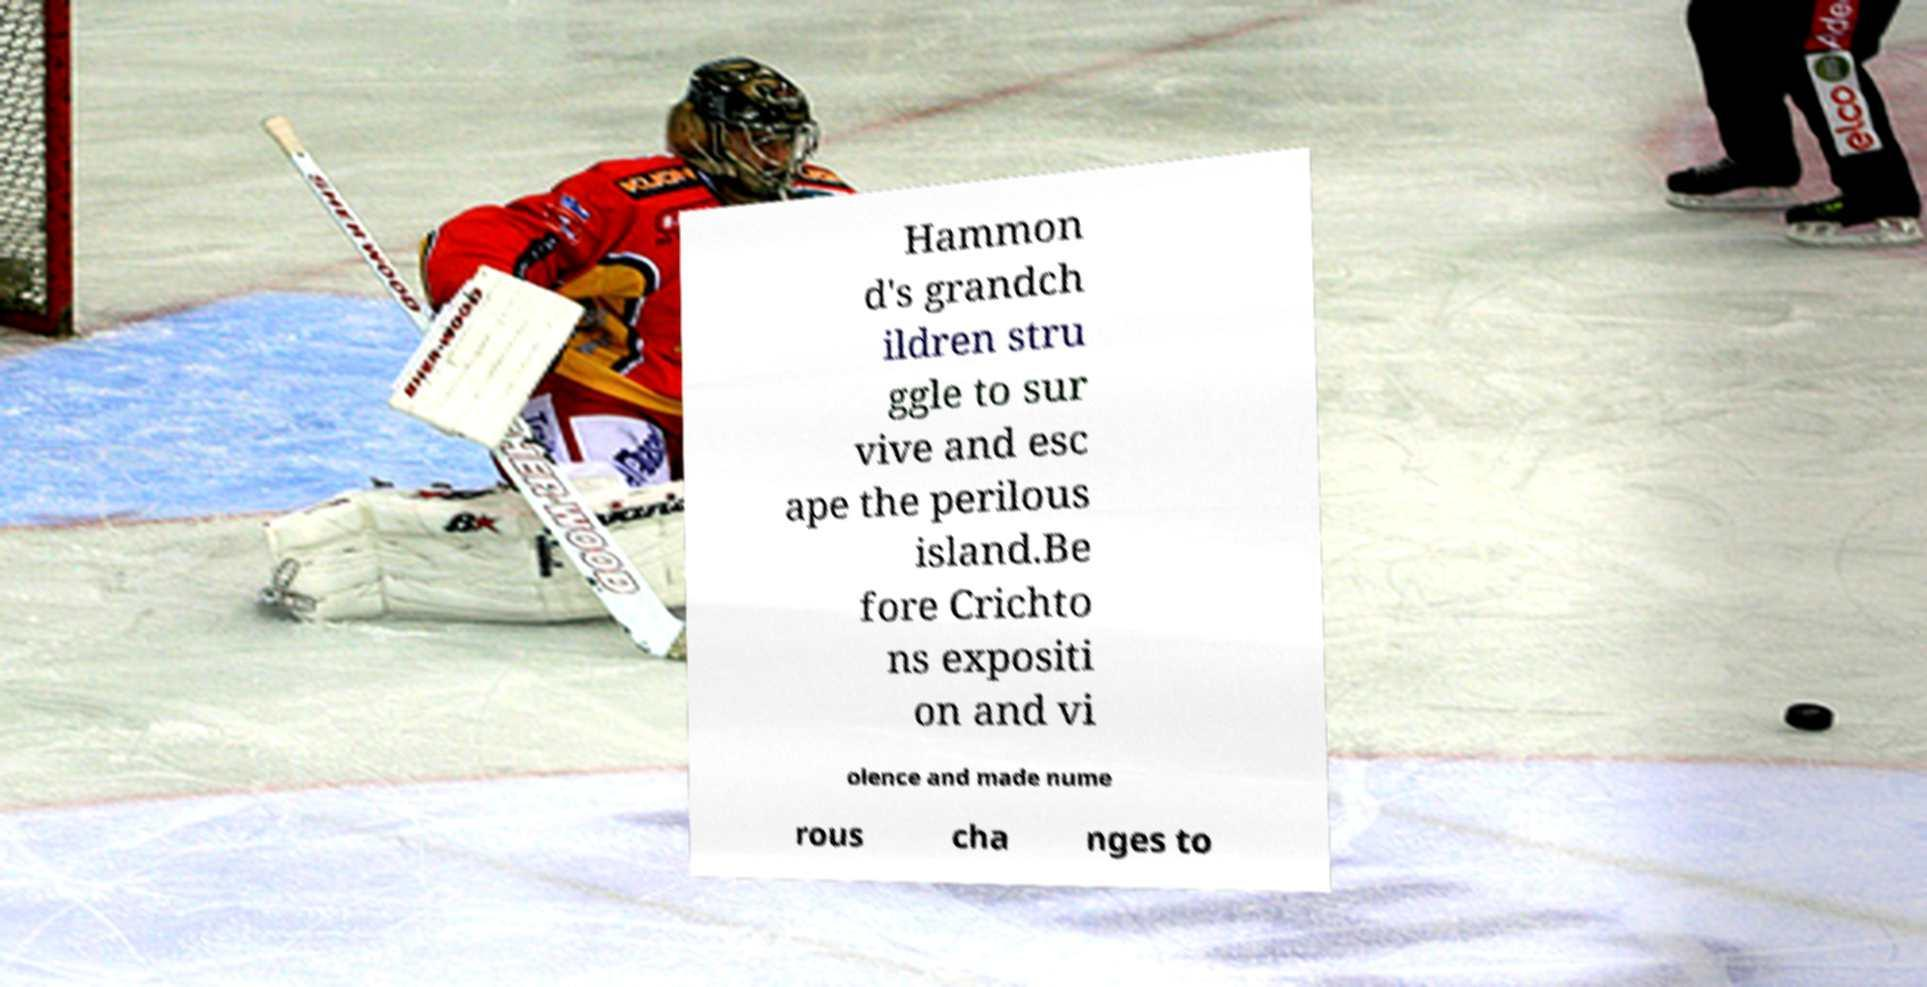What messages or text are displayed in this image? I need them in a readable, typed format. Hammon d's grandch ildren stru ggle to sur vive and esc ape the perilous island.Be fore Crichto ns expositi on and vi olence and made nume rous cha nges to 